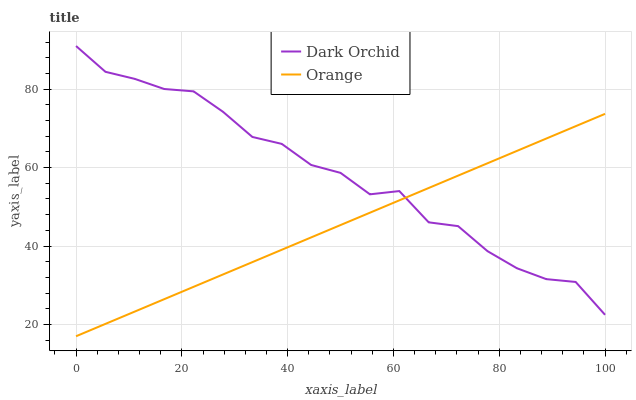Does Dark Orchid have the minimum area under the curve?
Answer yes or no. No. Is Dark Orchid the smoothest?
Answer yes or no. No. Does Dark Orchid have the lowest value?
Answer yes or no. No. 